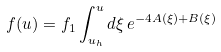<formula> <loc_0><loc_0><loc_500><loc_500>\ f ( u ) = f _ { 1 } \int _ { u _ { h } } ^ { u } d \xi \, e ^ { - 4 A ( \xi ) + B ( \xi ) }</formula> 